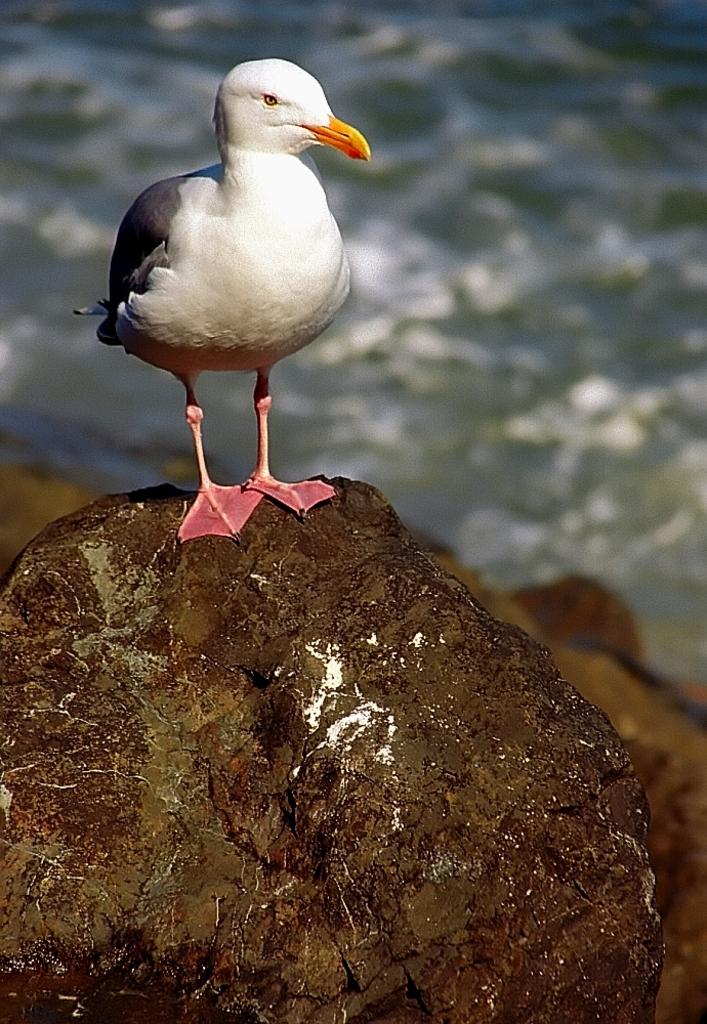What type of animal can be seen in the image? There is a bird in the image. Where is the bird located? The bird is standing on a rock. What can be seen in the background of the image? There is water visible in the background of the image. What type of plants can be seen growing on the bird's head in the image? There are no plants visible on the bird's head in the image. 